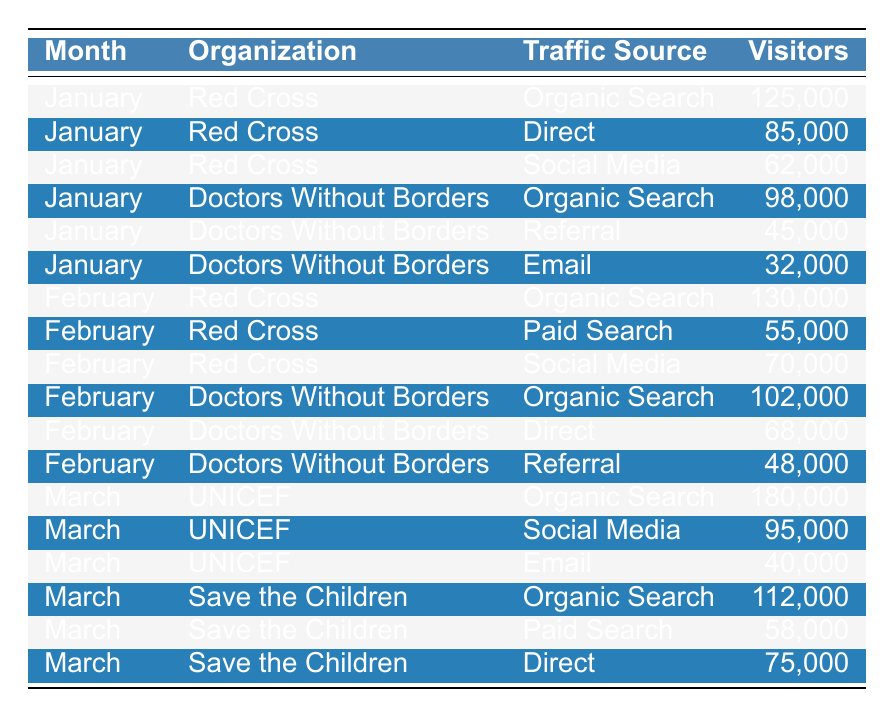What is the total number of visitors from the "Organic Search" traffic source for the Red Cross in January? The table shows that in January, the Red Cross had 125,000 visitors from Organic Search. Since this is the only entry under that traffic source for that month, the total number is 125,000.
Answer: 125000 What was the traffic source that brought the least visitors to Doctors Without Borders in January? In January, Doctors Without Borders had three traffic sources listed: Organic Search (98,000), Referral (45,000), and Email (32,000). The smallest number is from Email, with 32,000 visitors.
Answer: Email How many visitors did UNICEF receive through Social Media in March? The table lists UNICEF's traffic sources in March, showing that they received 95,000 visitors from Social Media.
Answer: 95000 Which organization had the highest total traffic in February, and how many visitors did they receive? In February, Red Cross had three traffic sources totaling visitors: Organic Search (130,000) + Paid Search (55,000) + Social Media (70,000) = 255,000. Doctors Without Borders had Organic Search (102,000) + Direct (68,000) + Referral (48,000) = 218,000. Red Cross had the highest total with 255,000 visitors.
Answer: Red Cross, 255000 What traffic source contributed to more visitors for Save the Children in March: Paid Search or Direct? Save the Children had 58,000 visitors from Paid Search and 75,000 from Direct in March. Since 75,000 is greater than 58,000, Direct contributed more visitors.
Answer: Direct What is the average number of visitors across all traffic sources for Doctors Without Borders in January? In January, Doctors Without Borders had three traffic sources: Organic Search (98,000), Referral (45,000), and Email (32,000). The average is calculated as (98,000 + 45,000 + 32,000) / 3 = 175,000 / 3 = 58,333.33.
Answer: 58333.33 Was there a growth in Organic Search visitors for the Red Cross from January to February? In January, the Red Cross received 125,000 visitors from Organic Search, and in February, they received 130,000. This shows a growth of 5,000 visitors from January to February, indicating positive growth.
Answer: Yes How many more total visitors did UNICEF receive in March compared to Doctors Without Borders in February? UNICEF had 180,000 visitors in March, while Doctors Without Borders had a total of 102,000 (Organic Search) + 68,000 (Direct) + 48,000 (Referral) = 218,000 visitors in February. The difference is 180,000 - 218,000 = -38,000, meaning UNICEF received 38,000 fewer visitors.
Answer: -38000 What percentage of Red Cross's total visitors in January came from Social Media? The visitors from Red Cross in January totaled 125,000 (Organic Search) + 85,000 (Direct) + 62,000 (Social Media) = 272,000. The number from Social Media, 62,000, makes up (62,000 / 272,000) * 100 = 22.79%.
Answer: 22.79% In February, did the total visitors from the Traffic Source "Referral" increase, decrease, or stay the same for Doctors Without Borders compared to January? In January, Doctors Without Borders had 45,000 visitors from Referral, and in February, they had 48,000. This indicates an increase in the number of Referral visitors, as 48,000 is greater than 45,000.
Answer: Increase 